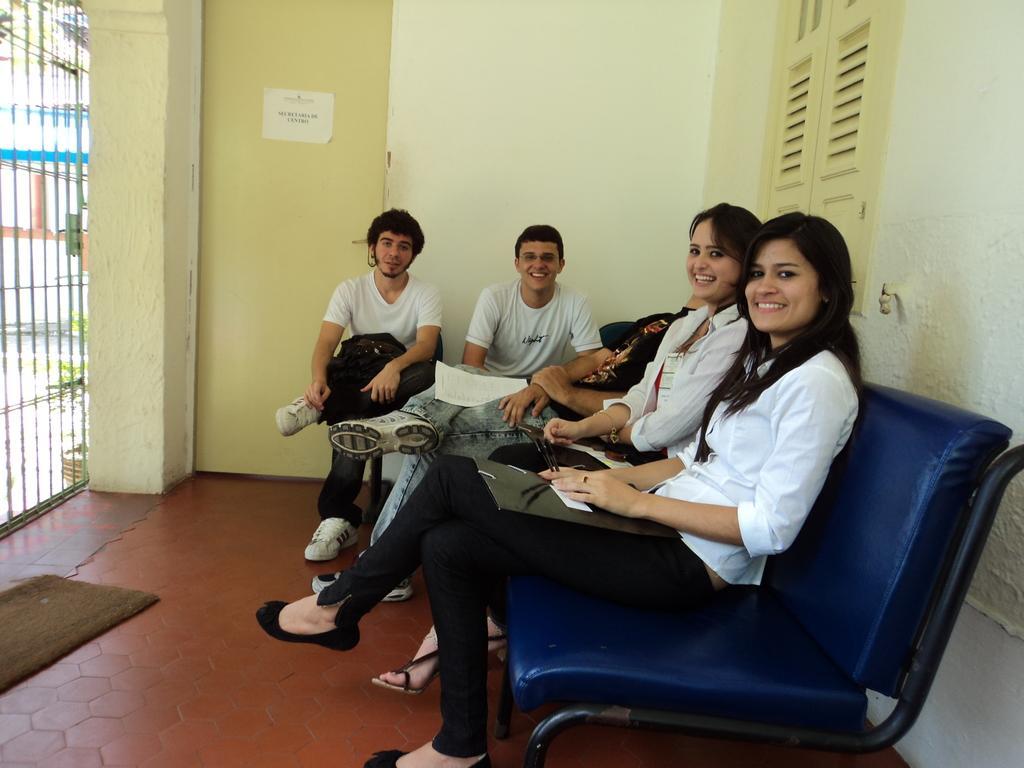Describe this image in one or two sentences. In this picture we can see two men, two women are smiling, sitting on chairs and in front of them we can see papers, rods, mat on the floor and at the back of them we can see a door with a poster on it, walls, window and some objects and in the background it is blurry. 